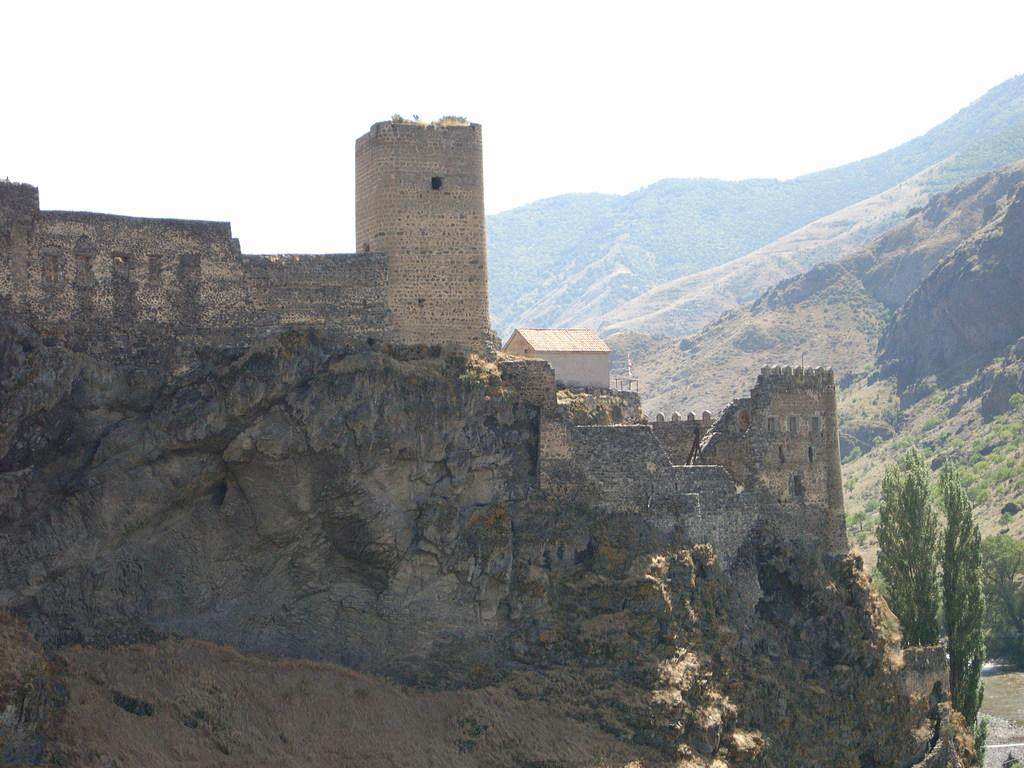What is the main structure in the image? There is a castle in the image. Where is the castle located? The castle is on a hill. What can be seen in the bottom right corner of the image? There are trees in the bottom right corner of the image. What is visible in the background of the image? There are hills and the sky visible in the background of the image. What type of alley can be seen near the castle in the image? There is no alley present in the image; it features a castle on a hill with trees, hills, and sky in the background. 